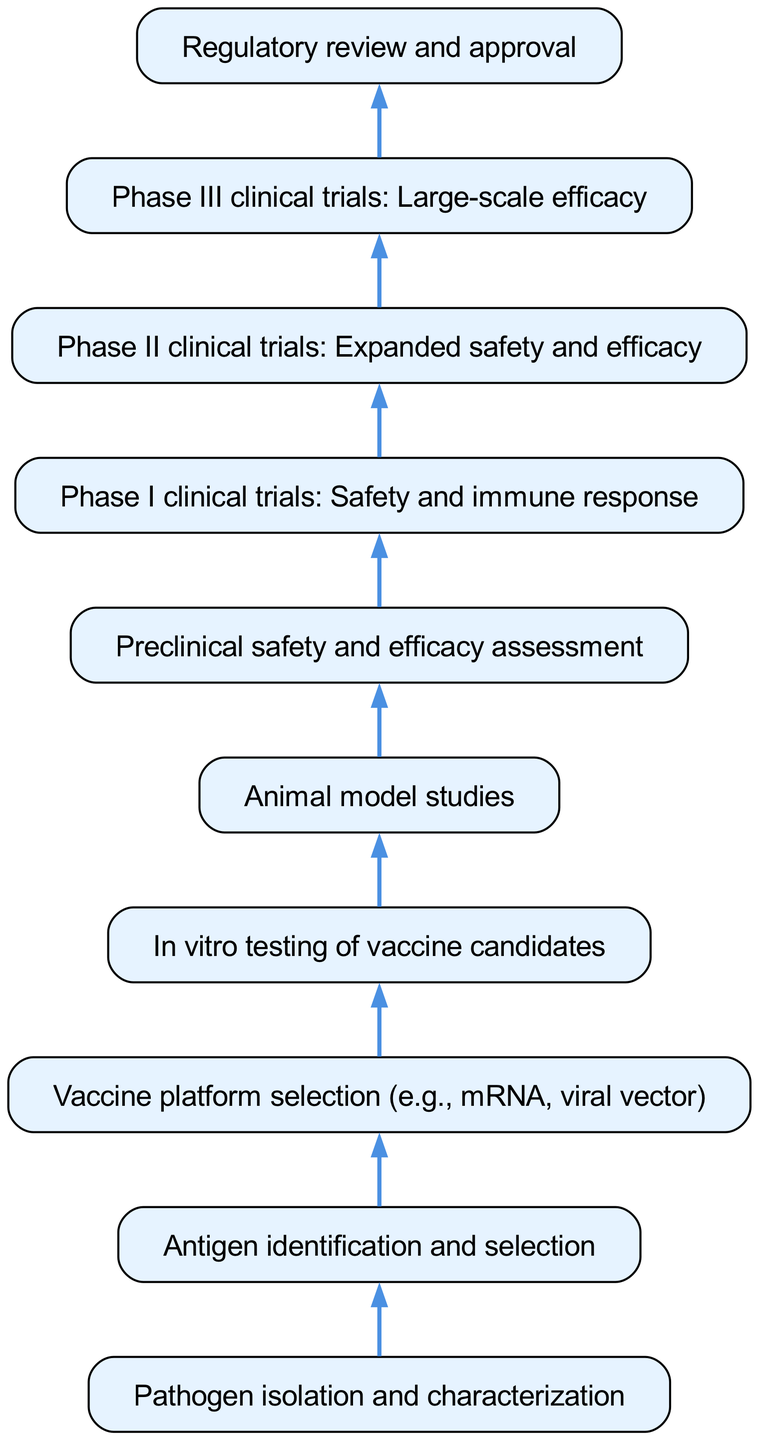What is the first step in the vaccine development process? The first step in the diagram is "Pathogen isolation and characterization," which is indicated as the starting point at the bottom of the flow chart.
Answer: Pathogen isolation and characterization How many total nodes are in the diagram? By counting all the distinct elements listed in the data, there are a total of 10 nodes associated with the vaccine development process.
Answer: 10 What follows after "In vitro testing of vaccine candidates"? The sequence of the diagram indicates that "In vitro testing of vaccine candidates" leads directly to "Animal model studies," as there is a directed edge connecting these two nodes.
Answer: Animal model studies Which phase comes before the "Phase III clinical trials"? Reviewing the connections in the diagram shows that "Phase II clinical trials: Expanded safety and efficacy" occurs before "Phase III clinical trials: Large-scale efficacy," as it is the immediate predecessor in the flow.
Answer: Phase II clinical trials: Expanded safety and efficacy What is the final step before regulatory approval? The diagram shows "Phase III clinical trials: Large-scale efficacy" as the last step before the process moves to "Regulatory review and approval," which highlights its significance in the flow of vaccine development.
Answer: Phase III clinical trials: Large-scale efficacy Explain the relationship between "Preclinical safety and efficacy assessment" and "Phase I clinical trials." Upon examining the flow, "Preclinical safety and efficacy assessment" comes directly before "Phase I clinical trials: Safety and immune response." This relationship indicates that successful completion of preclinical assessments is a prerequisite for commencing Phase I trials.
Answer: Preclinical safety and efficacy assessment What type of vaccine platform can be selected according to the diagram? The diagram specifies that 'Vaccine platform selection' can include options like mRNA or viral vector, as these are commonly recognized platforms in modern vaccine development.
Answer: mRNA, viral vector Which step follows "Animal model studies" in the vaccine development process? According to the connections mapped in the diagram, "Animal model studies" is succeeded by "Preclinical safety and efficacy assessment," indicating the order of operations in the development process.
Answer: Preclinical safety and efficacy assessment 